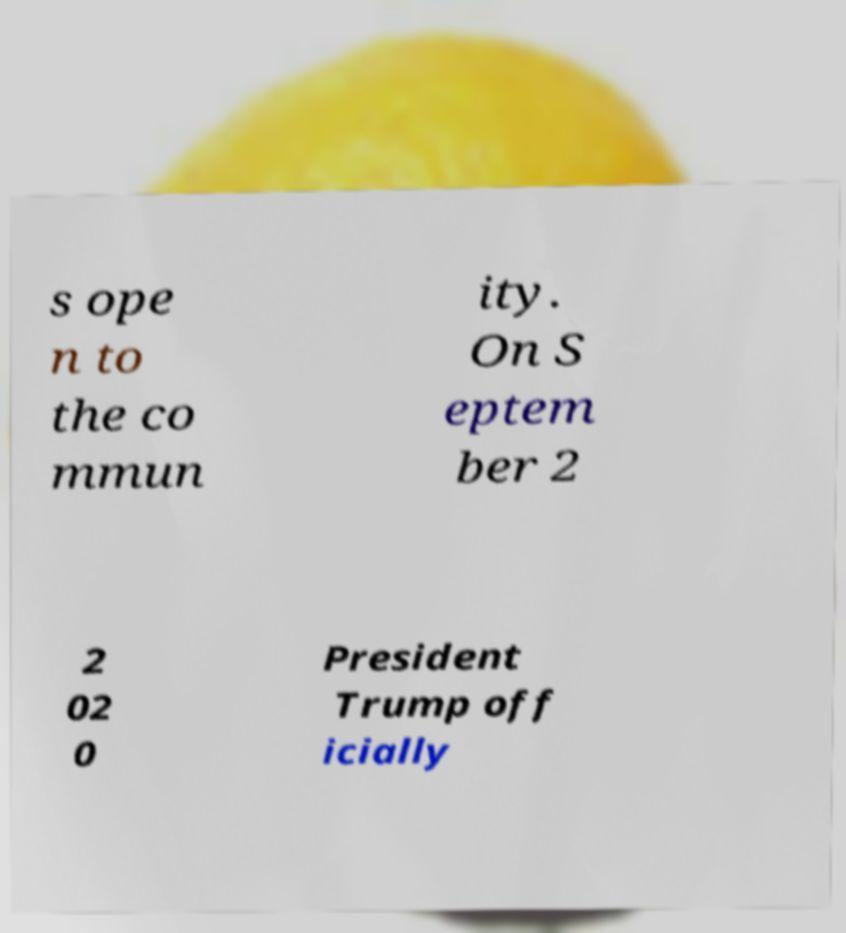Can you read and provide the text displayed in the image?This photo seems to have some interesting text. Can you extract and type it out for me? s ope n to the co mmun ity. On S eptem ber 2 2 02 0 President Trump off icially 